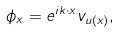Convert formula to latex. <formula><loc_0><loc_0><loc_500><loc_500>\phi _ { x } = e ^ { i k \cdot x } v _ { u ( x ) } ,</formula> 